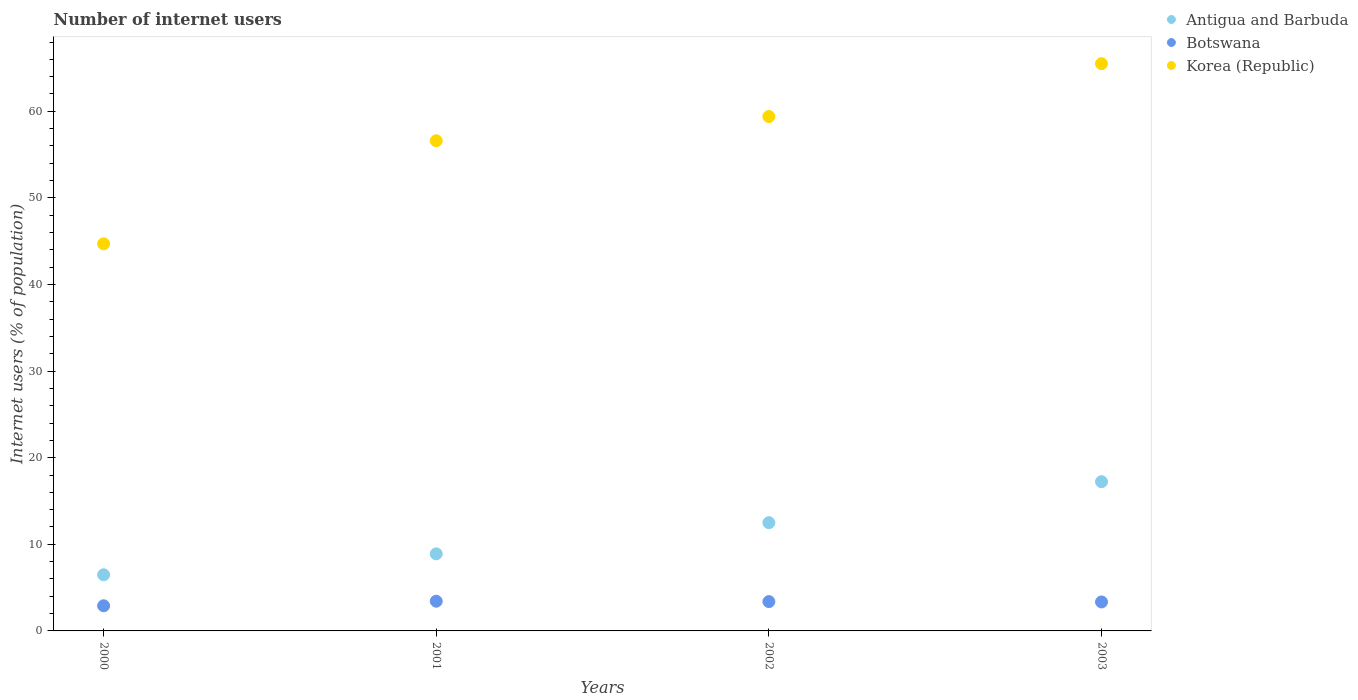Is the number of dotlines equal to the number of legend labels?
Your answer should be compact. Yes. What is the number of internet users in Botswana in 2001?
Give a very brief answer. 3.43. Across all years, what is the maximum number of internet users in Korea (Republic)?
Your answer should be very brief. 65.5. Across all years, what is the minimum number of internet users in Korea (Republic)?
Provide a short and direct response. 44.7. In which year was the number of internet users in Antigua and Barbuda maximum?
Give a very brief answer. 2003. What is the total number of internet users in Botswana in the graph?
Your response must be concise. 13.06. What is the difference between the number of internet users in Antigua and Barbuda in 2001 and that in 2003?
Ensure brevity in your answer.  -8.33. What is the difference between the number of internet users in Korea (Republic) in 2003 and the number of internet users in Botswana in 2001?
Ensure brevity in your answer.  62.07. What is the average number of internet users in Korea (Republic) per year?
Your answer should be very brief. 56.55. In the year 2000, what is the difference between the number of internet users in Botswana and number of internet users in Antigua and Barbuda?
Keep it short and to the point. -3.58. What is the ratio of the number of internet users in Botswana in 2000 to that in 2002?
Your response must be concise. 0.86. Is the difference between the number of internet users in Botswana in 2000 and 2001 greater than the difference between the number of internet users in Antigua and Barbuda in 2000 and 2001?
Make the answer very short. Yes. What is the difference between the highest and the second highest number of internet users in Botswana?
Provide a short and direct response. 0.04. What is the difference between the highest and the lowest number of internet users in Korea (Republic)?
Your answer should be very brief. 20.8. In how many years, is the number of internet users in Antigua and Barbuda greater than the average number of internet users in Antigua and Barbuda taken over all years?
Offer a very short reply. 2. Is the sum of the number of internet users in Botswana in 2000 and 2001 greater than the maximum number of internet users in Korea (Republic) across all years?
Your answer should be compact. No. Is it the case that in every year, the sum of the number of internet users in Korea (Republic) and number of internet users in Antigua and Barbuda  is greater than the number of internet users in Botswana?
Keep it short and to the point. Yes. Does the number of internet users in Korea (Republic) monotonically increase over the years?
Provide a short and direct response. Yes. Is the number of internet users in Antigua and Barbuda strictly less than the number of internet users in Korea (Republic) over the years?
Offer a very short reply. Yes. How many dotlines are there?
Your answer should be very brief. 3. How many years are there in the graph?
Give a very brief answer. 4. What is the difference between two consecutive major ticks on the Y-axis?
Your answer should be very brief. 10. Where does the legend appear in the graph?
Offer a terse response. Top right. How many legend labels are there?
Make the answer very short. 3. How are the legend labels stacked?
Your response must be concise. Vertical. What is the title of the graph?
Offer a very short reply. Number of internet users. Does "St. Lucia" appear as one of the legend labels in the graph?
Provide a short and direct response. No. What is the label or title of the Y-axis?
Your answer should be compact. Internet users (% of population). What is the Internet users (% of population) in Antigua and Barbuda in 2000?
Your answer should be very brief. 6.48. What is the Internet users (% of population) of Botswana in 2000?
Ensure brevity in your answer.  2.9. What is the Internet users (% of population) of Korea (Republic) in 2000?
Provide a succinct answer. 44.7. What is the Internet users (% of population) in Antigua and Barbuda in 2001?
Give a very brief answer. 8.9. What is the Internet users (% of population) in Botswana in 2001?
Ensure brevity in your answer.  3.43. What is the Internet users (% of population) in Korea (Republic) in 2001?
Make the answer very short. 56.6. What is the Internet users (% of population) of Botswana in 2002?
Make the answer very short. 3.39. What is the Internet users (% of population) in Korea (Republic) in 2002?
Ensure brevity in your answer.  59.4. What is the Internet users (% of population) in Antigua and Barbuda in 2003?
Your answer should be compact. 17.23. What is the Internet users (% of population) in Botswana in 2003?
Offer a terse response. 3.35. What is the Internet users (% of population) in Korea (Republic) in 2003?
Offer a very short reply. 65.5. Across all years, what is the maximum Internet users (% of population) of Antigua and Barbuda?
Your response must be concise. 17.23. Across all years, what is the maximum Internet users (% of population) in Botswana?
Offer a very short reply. 3.43. Across all years, what is the maximum Internet users (% of population) in Korea (Republic)?
Provide a short and direct response. 65.5. Across all years, what is the minimum Internet users (% of population) in Antigua and Barbuda?
Provide a succinct answer. 6.48. Across all years, what is the minimum Internet users (% of population) of Botswana?
Make the answer very short. 2.9. Across all years, what is the minimum Internet users (% of population) in Korea (Republic)?
Offer a terse response. 44.7. What is the total Internet users (% of population) of Antigua and Barbuda in the graph?
Offer a very short reply. 45.11. What is the total Internet users (% of population) of Botswana in the graph?
Your response must be concise. 13.06. What is the total Internet users (% of population) of Korea (Republic) in the graph?
Your response must be concise. 226.2. What is the difference between the Internet users (% of population) of Antigua and Barbuda in 2000 and that in 2001?
Your response must be concise. -2.42. What is the difference between the Internet users (% of population) in Botswana in 2000 and that in 2001?
Offer a terse response. -0.53. What is the difference between the Internet users (% of population) in Antigua and Barbuda in 2000 and that in 2002?
Your answer should be very brief. -6.02. What is the difference between the Internet users (% of population) of Botswana in 2000 and that in 2002?
Keep it short and to the point. -0.48. What is the difference between the Internet users (% of population) of Korea (Republic) in 2000 and that in 2002?
Ensure brevity in your answer.  -14.7. What is the difference between the Internet users (% of population) in Antigua and Barbuda in 2000 and that in 2003?
Ensure brevity in your answer.  -10.75. What is the difference between the Internet users (% of population) in Botswana in 2000 and that in 2003?
Offer a very short reply. -0.44. What is the difference between the Internet users (% of population) in Korea (Republic) in 2000 and that in 2003?
Make the answer very short. -20.8. What is the difference between the Internet users (% of population) of Antigua and Barbuda in 2001 and that in 2002?
Ensure brevity in your answer.  -3.6. What is the difference between the Internet users (% of population) in Botswana in 2001 and that in 2002?
Provide a short and direct response. 0.04. What is the difference between the Internet users (% of population) in Korea (Republic) in 2001 and that in 2002?
Provide a short and direct response. -2.8. What is the difference between the Internet users (% of population) of Antigua and Barbuda in 2001 and that in 2003?
Give a very brief answer. -8.33. What is the difference between the Internet users (% of population) in Botswana in 2001 and that in 2003?
Your answer should be compact. 0.09. What is the difference between the Internet users (% of population) in Korea (Republic) in 2001 and that in 2003?
Offer a very short reply. -8.9. What is the difference between the Internet users (% of population) in Antigua and Barbuda in 2002 and that in 2003?
Your answer should be compact. -4.73. What is the difference between the Internet users (% of population) of Botswana in 2002 and that in 2003?
Provide a succinct answer. 0.04. What is the difference between the Internet users (% of population) of Antigua and Barbuda in 2000 and the Internet users (% of population) of Botswana in 2001?
Keep it short and to the point. 3.05. What is the difference between the Internet users (% of population) in Antigua and Barbuda in 2000 and the Internet users (% of population) in Korea (Republic) in 2001?
Your answer should be very brief. -50.12. What is the difference between the Internet users (% of population) of Botswana in 2000 and the Internet users (% of population) of Korea (Republic) in 2001?
Make the answer very short. -53.7. What is the difference between the Internet users (% of population) in Antigua and Barbuda in 2000 and the Internet users (% of population) in Botswana in 2002?
Provide a short and direct response. 3.1. What is the difference between the Internet users (% of population) of Antigua and Barbuda in 2000 and the Internet users (% of population) of Korea (Republic) in 2002?
Provide a succinct answer. -52.92. What is the difference between the Internet users (% of population) of Botswana in 2000 and the Internet users (% of population) of Korea (Republic) in 2002?
Keep it short and to the point. -56.5. What is the difference between the Internet users (% of population) of Antigua and Barbuda in 2000 and the Internet users (% of population) of Botswana in 2003?
Make the answer very short. 3.14. What is the difference between the Internet users (% of population) of Antigua and Barbuda in 2000 and the Internet users (% of population) of Korea (Republic) in 2003?
Your answer should be very brief. -59.02. What is the difference between the Internet users (% of population) in Botswana in 2000 and the Internet users (% of population) in Korea (Republic) in 2003?
Your response must be concise. -62.6. What is the difference between the Internet users (% of population) in Antigua and Barbuda in 2001 and the Internet users (% of population) in Botswana in 2002?
Provide a succinct answer. 5.51. What is the difference between the Internet users (% of population) in Antigua and Barbuda in 2001 and the Internet users (% of population) in Korea (Republic) in 2002?
Make the answer very short. -50.5. What is the difference between the Internet users (% of population) of Botswana in 2001 and the Internet users (% of population) of Korea (Republic) in 2002?
Make the answer very short. -55.97. What is the difference between the Internet users (% of population) of Antigua and Barbuda in 2001 and the Internet users (% of population) of Botswana in 2003?
Your answer should be very brief. 5.55. What is the difference between the Internet users (% of population) in Antigua and Barbuda in 2001 and the Internet users (% of population) in Korea (Republic) in 2003?
Make the answer very short. -56.6. What is the difference between the Internet users (% of population) of Botswana in 2001 and the Internet users (% of population) of Korea (Republic) in 2003?
Provide a succinct answer. -62.07. What is the difference between the Internet users (% of population) of Antigua and Barbuda in 2002 and the Internet users (% of population) of Botswana in 2003?
Provide a succinct answer. 9.15. What is the difference between the Internet users (% of population) of Antigua and Barbuda in 2002 and the Internet users (% of population) of Korea (Republic) in 2003?
Ensure brevity in your answer.  -53. What is the difference between the Internet users (% of population) in Botswana in 2002 and the Internet users (% of population) in Korea (Republic) in 2003?
Ensure brevity in your answer.  -62.11. What is the average Internet users (% of population) of Antigua and Barbuda per year?
Offer a very short reply. 11.28. What is the average Internet users (% of population) of Botswana per year?
Provide a succinct answer. 3.27. What is the average Internet users (% of population) in Korea (Republic) per year?
Keep it short and to the point. 56.55. In the year 2000, what is the difference between the Internet users (% of population) of Antigua and Barbuda and Internet users (% of population) of Botswana?
Keep it short and to the point. 3.58. In the year 2000, what is the difference between the Internet users (% of population) in Antigua and Barbuda and Internet users (% of population) in Korea (Republic)?
Your answer should be compact. -38.22. In the year 2000, what is the difference between the Internet users (% of population) in Botswana and Internet users (% of population) in Korea (Republic)?
Your answer should be compact. -41.8. In the year 2001, what is the difference between the Internet users (% of population) in Antigua and Barbuda and Internet users (% of population) in Botswana?
Offer a very short reply. 5.47. In the year 2001, what is the difference between the Internet users (% of population) of Antigua and Barbuda and Internet users (% of population) of Korea (Republic)?
Your answer should be compact. -47.7. In the year 2001, what is the difference between the Internet users (% of population) in Botswana and Internet users (% of population) in Korea (Republic)?
Provide a short and direct response. -53.17. In the year 2002, what is the difference between the Internet users (% of population) in Antigua and Barbuda and Internet users (% of population) in Botswana?
Your answer should be very brief. 9.11. In the year 2002, what is the difference between the Internet users (% of population) in Antigua and Barbuda and Internet users (% of population) in Korea (Republic)?
Provide a short and direct response. -46.9. In the year 2002, what is the difference between the Internet users (% of population) in Botswana and Internet users (% of population) in Korea (Republic)?
Keep it short and to the point. -56.01. In the year 2003, what is the difference between the Internet users (% of population) of Antigua and Barbuda and Internet users (% of population) of Botswana?
Ensure brevity in your answer.  13.88. In the year 2003, what is the difference between the Internet users (% of population) in Antigua and Barbuda and Internet users (% of population) in Korea (Republic)?
Provide a short and direct response. -48.27. In the year 2003, what is the difference between the Internet users (% of population) of Botswana and Internet users (% of population) of Korea (Republic)?
Provide a succinct answer. -62.15. What is the ratio of the Internet users (% of population) of Antigua and Barbuda in 2000 to that in 2001?
Your answer should be very brief. 0.73. What is the ratio of the Internet users (% of population) in Botswana in 2000 to that in 2001?
Provide a succinct answer. 0.85. What is the ratio of the Internet users (% of population) of Korea (Republic) in 2000 to that in 2001?
Give a very brief answer. 0.79. What is the ratio of the Internet users (% of population) in Antigua and Barbuda in 2000 to that in 2002?
Give a very brief answer. 0.52. What is the ratio of the Internet users (% of population) in Botswana in 2000 to that in 2002?
Give a very brief answer. 0.86. What is the ratio of the Internet users (% of population) in Korea (Republic) in 2000 to that in 2002?
Ensure brevity in your answer.  0.75. What is the ratio of the Internet users (% of population) of Antigua and Barbuda in 2000 to that in 2003?
Make the answer very short. 0.38. What is the ratio of the Internet users (% of population) of Botswana in 2000 to that in 2003?
Provide a succinct answer. 0.87. What is the ratio of the Internet users (% of population) in Korea (Republic) in 2000 to that in 2003?
Offer a very short reply. 0.68. What is the ratio of the Internet users (% of population) of Antigua and Barbuda in 2001 to that in 2002?
Give a very brief answer. 0.71. What is the ratio of the Internet users (% of population) of Botswana in 2001 to that in 2002?
Provide a short and direct response. 1.01. What is the ratio of the Internet users (% of population) of Korea (Republic) in 2001 to that in 2002?
Your answer should be compact. 0.95. What is the ratio of the Internet users (% of population) of Antigua and Barbuda in 2001 to that in 2003?
Provide a short and direct response. 0.52. What is the ratio of the Internet users (% of population) of Botswana in 2001 to that in 2003?
Offer a very short reply. 1.03. What is the ratio of the Internet users (% of population) of Korea (Republic) in 2001 to that in 2003?
Make the answer very short. 0.86. What is the ratio of the Internet users (% of population) in Antigua and Barbuda in 2002 to that in 2003?
Ensure brevity in your answer.  0.73. What is the ratio of the Internet users (% of population) of Botswana in 2002 to that in 2003?
Your response must be concise. 1.01. What is the ratio of the Internet users (% of population) in Korea (Republic) in 2002 to that in 2003?
Ensure brevity in your answer.  0.91. What is the difference between the highest and the second highest Internet users (% of population) of Antigua and Barbuda?
Your answer should be very brief. 4.73. What is the difference between the highest and the second highest Internet users (% of population) in Botswana?
Give a very brief answer. 0.04. What is the difference between the highest and the lowest Internet users (% of population) in Antigua and Barbuda?
Make the answer very short. 10.75. What is the difference between the highest and the lowest Internet users (% of population) of Botswana?
Provide a short and direct response. 0.53. What is the difference between the highest and the lowest Internet users (% of population) in Korea (Republic)?
Offer a very short reply. 20.8. 